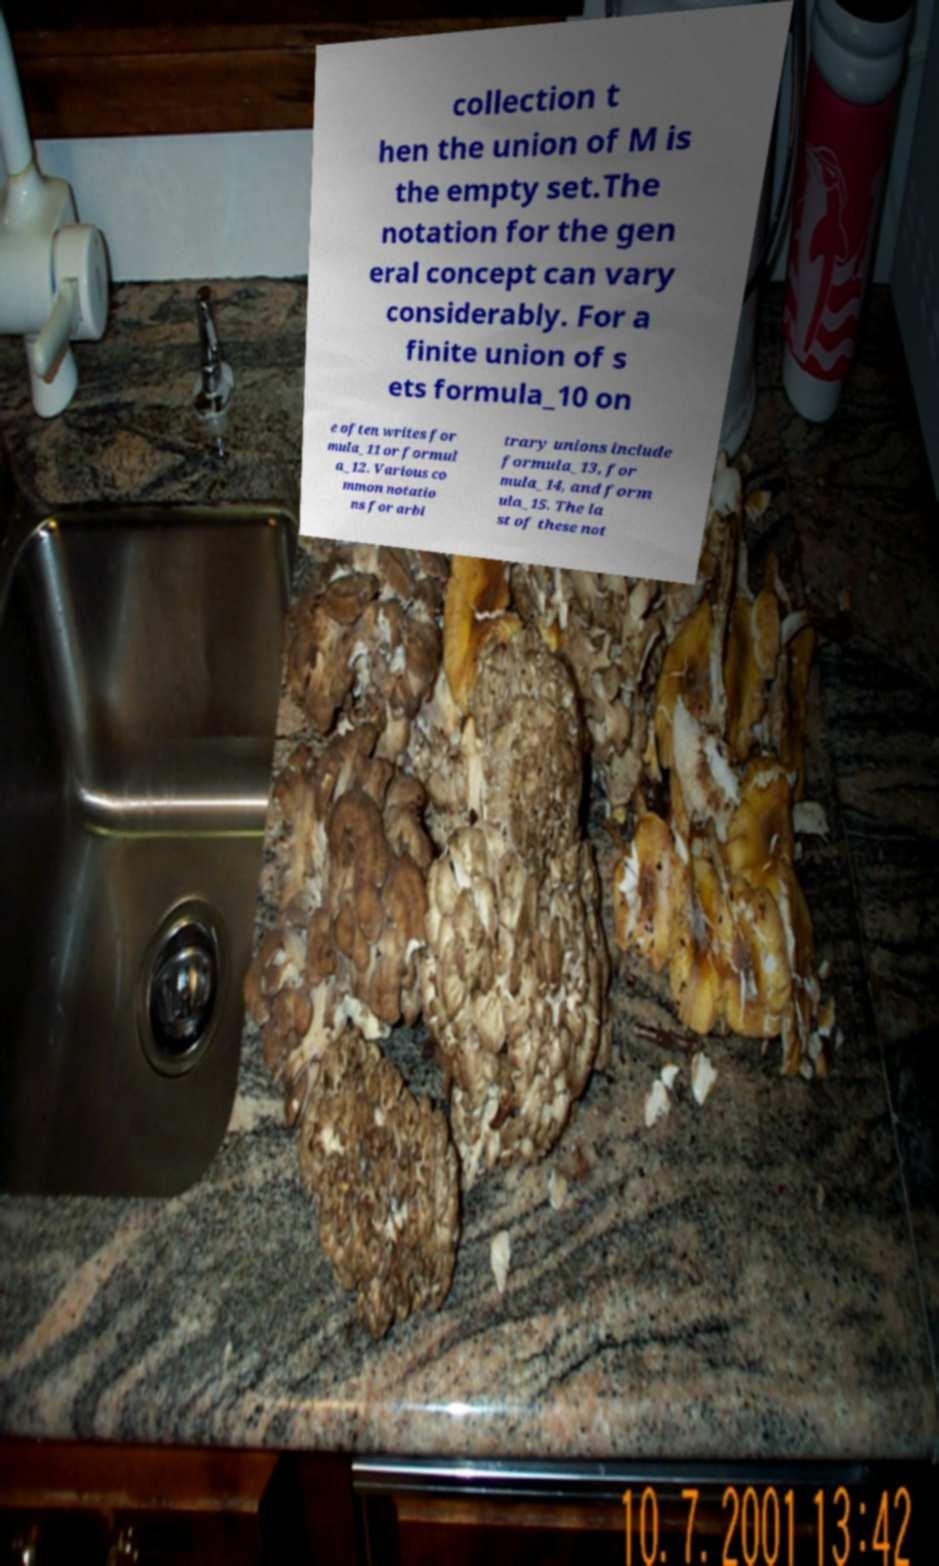What messages or text are displayed in this image? I need them in a readable, typed format. collection t hen the union of M is the empty set.The notation for the gen eral concept can vary considerably. For a finite union of s ets formula_10 on e often writes for mula_11 or formul a_12. Various co mmon notatio ns for arbi trary unions include formula_13, for mula_14, and form ula_15. The la st of these not 